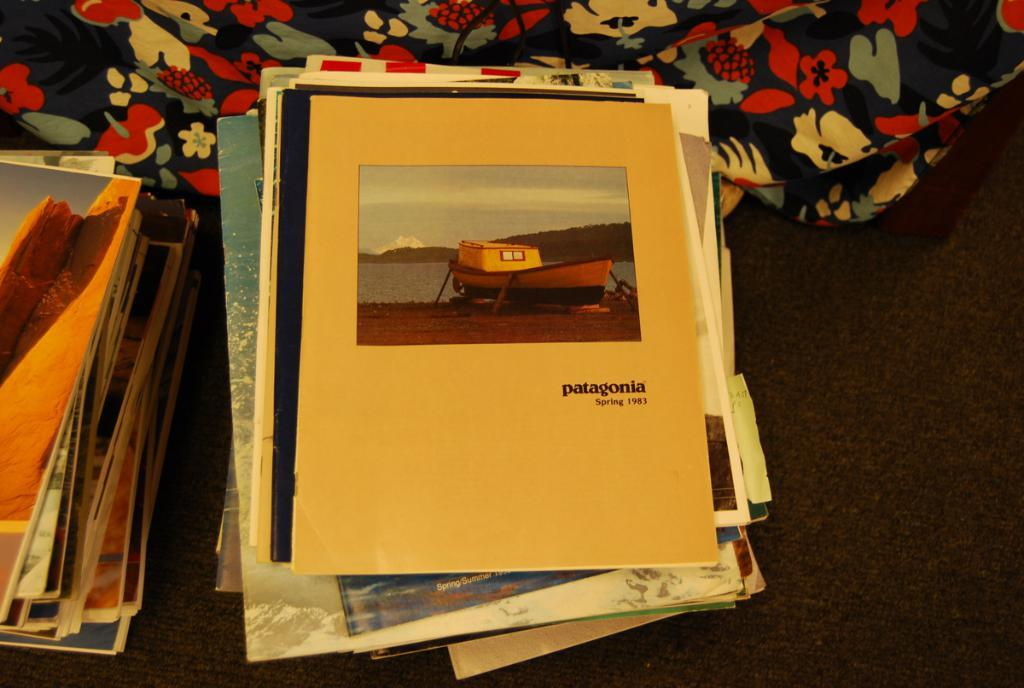What objects are on the platform in the image? There are books on a platform in the image. What is covering the platform? There is cloth on the platform. What is depicted on the book? The book has a picture of a boat. What else can be seen in the picture on the book? The picture also includes water, mountains, and sky. Is there any text on the book? Yes, there is writing on the book. What type of machine is used to clean the dust off the books in the image? There is no machine or dust present in the image; it only shows books on a platform with a cloth covering it. 